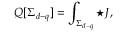Convert formula to latex. <formula><loc_0><loc_0><loc_500><loc_500>Q [ \Sigma _ { d - q } ] = \int _ { \Sigma _ { d - q } } { ^ { * } J } ,</formula> 